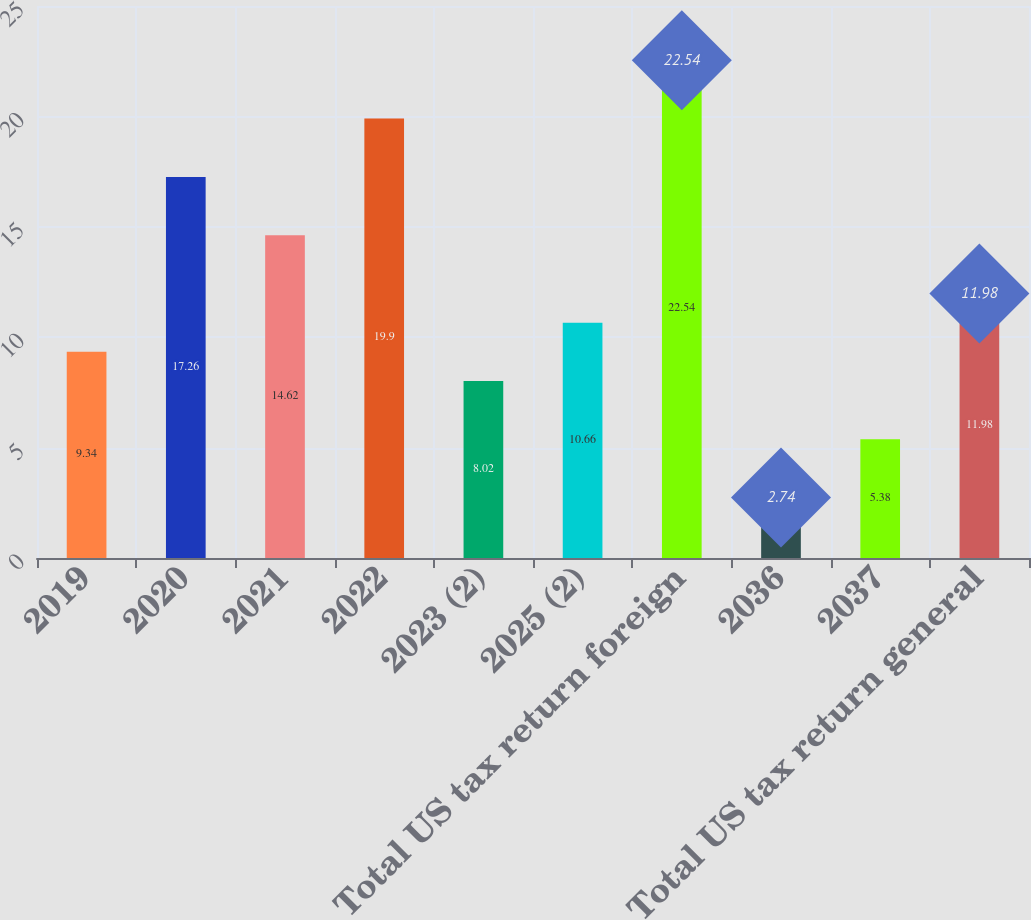Convert chart to OTSL. <chart><loc_0><loc_0><loc_500><loc_500><bar_chart><fcel>2019<fcel>2020<fcel>2021<fcel>2022<fcel>2023 (2)<fcel>2025 (2)<fcel>Total US tax return foreign<fcel>2036<fcel>2037<fcel>Total US tax return general<nl><fcel>9.34<fcel>17.26<fcel>14.62<fcel>19.9<fcel>8.02<fcel>10.66<fcel>22.54<fcel>2.74<fcel>5.38<fcel>11.98<nl></chart> 